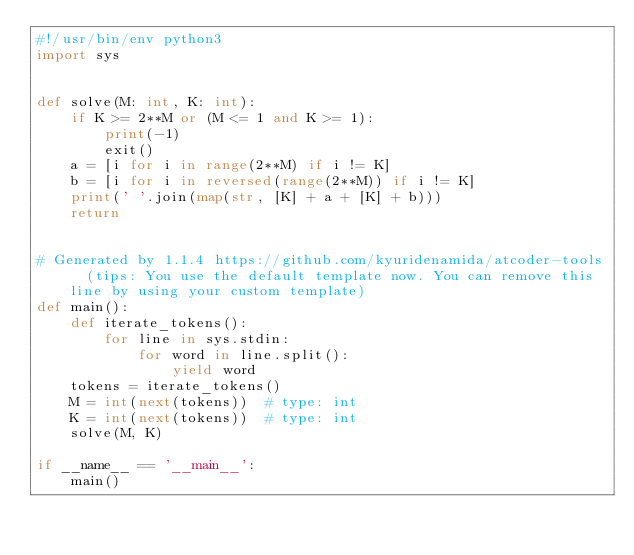Convert code to text. <code><loc_0><loc_0><loc_500><loc_500><_Python_>#!/usr/bin/env python3
import sys


def solve(M: int, K: int):
    if K >= 2**M or (M <= 1 and K >= 1):
        print(-1)
        exit()
    a = [i for i in range(2**M) if i != K]
    b = [i for i in reversed(range(2**M)) if i != K]
    print(' '.join(map(str, [K] + a + [K] + b)))
    return


# Generated by 1.1.4 https://github.com/kyuridenamida/atcoder-tools  (tips: You use the default template now. You can remove this line by using your custom template)
def main():
    def iterate_tokens():
        for line in sys.stdin:
            for word in line.split():
                yield word
    tokens = iterate_tokens()
    M = int(next(tokens))  # type: int
    K = int(next(tokens))  # type: int
    solve(M, K)

if __name__ == '__main__':
    main()
</code> 